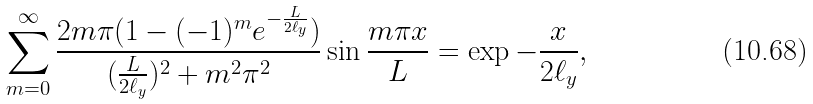<formula> <loc_0><loc_0><loc_500><loc_500>\sum _ { m = 0 } ^ { \infty } \frac { 2 m \pi ( 1 - ( - 1 ) ^ { m } e ^ { - \frac { L } { 2 \ell _ { y } } } ) } { ( \frac { L } { 2 \ell _ { y } } ) ^ { 2 } + m ^ { 2 } \pi ^ { 2 } } \sin { \frac { m \pi x } { L } } = \exp { - \frac { x } { 2 \ell _ { y } } } ,</formula> 